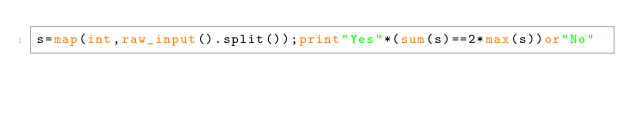<code> <loc_0><loc_0><loc_500><loc_500><_Python_>s=map(int,raw_input().split());print"Yes"*(sum(s)==2*max(s))or"No"</code> 